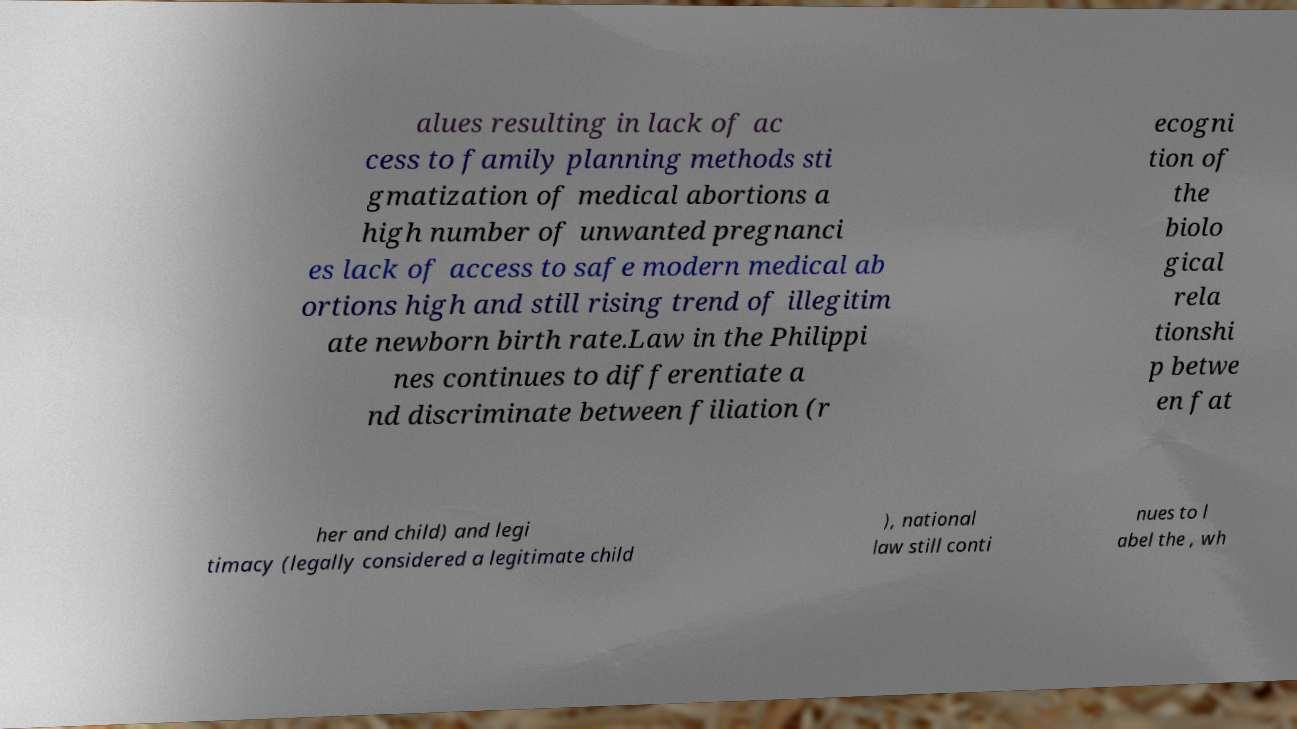Can you accurately transcribe the text from the provided image for me? alues resulting in lack of ac cess to family planning methods sti gmatization of medical abortions a high number of unwanted pregnanci es lack of access to safe modern medical ab ortions high and still rising trend of illegitim ate newborn birth rate.Law in the Philippi nes continues to differentiate a nd discriminate between filiation (r ecogni tion of the biolo gical rela tionshi p betwe en fat her and child) and legi timacy (legally considered a legitimate child ), national law still conti nues to l abel the , wh 